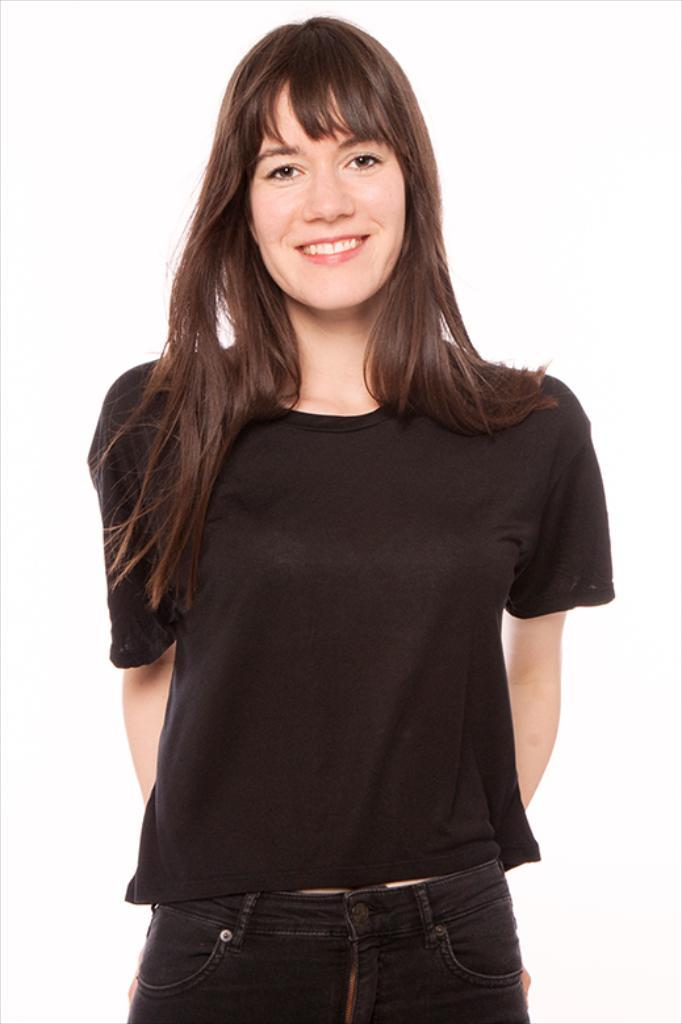What is the main subject of the image? There is a woman standing in the image. What is the woman's facial expression? The woman is smiling. What color is the background of the image? The background of the image is white. What type of bed is visible in the image? There is no bed present in the image; it features a woman standing with a white background. What emotion does the woman express in the image, other than happiness? The woman is only shown expressing happiness in the image, as she is smiling. 